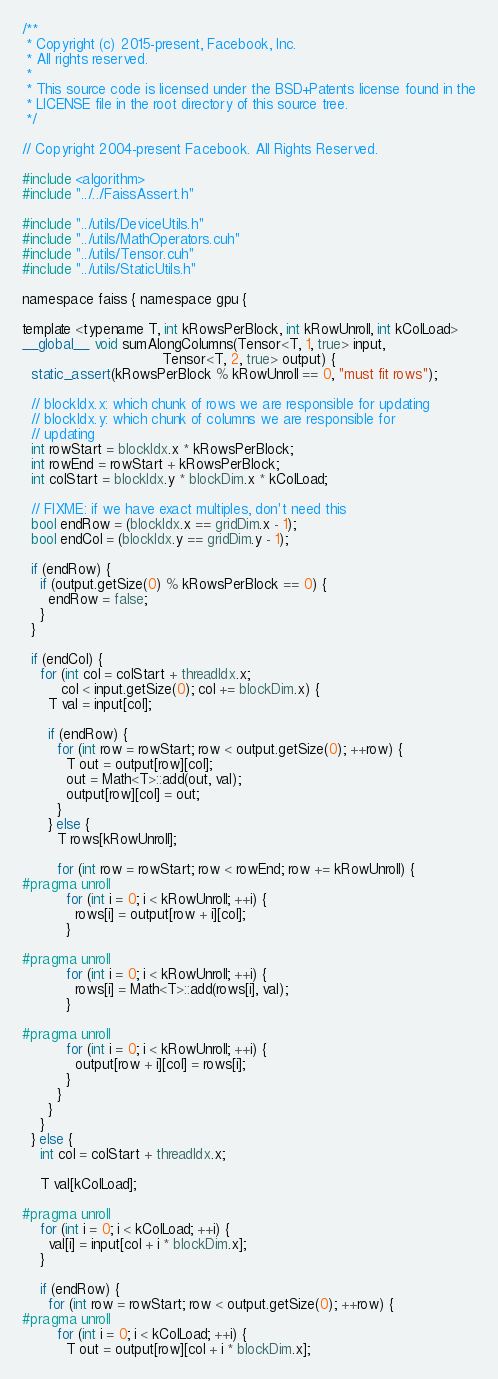Convert code to text. <code><loc_0><loc_0><loc_500><loc_500><_Cuda_>/**
 * Copyright (c) 2015-present, Facebook, Inc.
 * All rights reserved.
 *
 * This source code is licensed under the BSD+Patents license found in the
 * LICENSE file in the root directory of this source tree.
 */

// Copyright 2004-present Facebook. All Rights Reserved.

#include <algorithm>
#include "../../FaissAssert.h"

#include "../utils/DeviceUtils.h"
#include "../utils/MathOperators.cuh"
#include "../utils/Tensor.cuh"
#include "../utils/StaticUtils.h"

namespace faiss { namespace gpu {

template <typename T, int kRowsPerBlock, int kRowUnroll, int kColLoad>
__global__ void sumAlongColumns(Tensor<T, 1, true> input,
                                Tensor<T, 2, true> output) {
  static_assert(kRowsPerBlock % kRowUnroll == 0, "must fit rows");

  // blockIdx.x: which chunk of rows we are responsible for updating
  // blockIdx.y: which chunk of columns we are responsible for
  // updating
  int rowStart = blockIdx.x * kRowsPerBlock;
  int rowEnd = rowStart + kRowsPerBlock;
  int colStart = blockIdx.y * blockDim.x * kColLoad;

  // FIXME: if we have exact multiples, don't need this
  bool endRow = (blockIdx.x == gridDim.x - 1);
  bool endCol = (blockIdx.y == gridDim.y - 1);

  if (endRow) {
    if (output.getSize(0) % kRowsPerBlock == 0) {
      endRow = false;
    }
  }

  if (endCol) {
    for (int col = colStart + threadIdx.x;
         col < input.getSize(0); col += blockDim.x) {
      T val = input[col];

      if (endRow) {
        for (int row = rowStart; row < output.getSize(0); ++row) {
          T out = output[row][col];
          out = Math<T>::add(out, val);
          output[row][col] = out;
        }
      } else {
        T rows[kRowUnroll];

        for (int row = rowStart; row < rowEnd; row += kRowUnroll) {
#pragma unroll
          for (int i = 0; i < kRowUnroll; ++i) {
            rows[i] = output[row + i][col];
          }

#pragma unroll
          for (int i = 0; i < kRowUnroll; ++i) {
            rows[i] = Math<T>::add(rows[i], val);
          }

#pragma unroll
          for (int i = 0; i < kRowUnroll; ++i) {
            output[row + i][col] = rows[i];
          }
        }
      }
    }
  } else {
    int col = colStart + threadIdx.x;

    T val[kColLoad];

#pragma unroll
    for (int i = 0; i < kColLoad; ++i) {
      val[i] = input[col + i * blockDim.x];
    }

    if (endRow) {
      for (int row = rowStart; row < output.getSize(0); ++row) {
#pragma unroll
        for (int i = 0; i < kColLoad; ++i) {
          T out = output[row][col + i * blockDim.x];</code> 